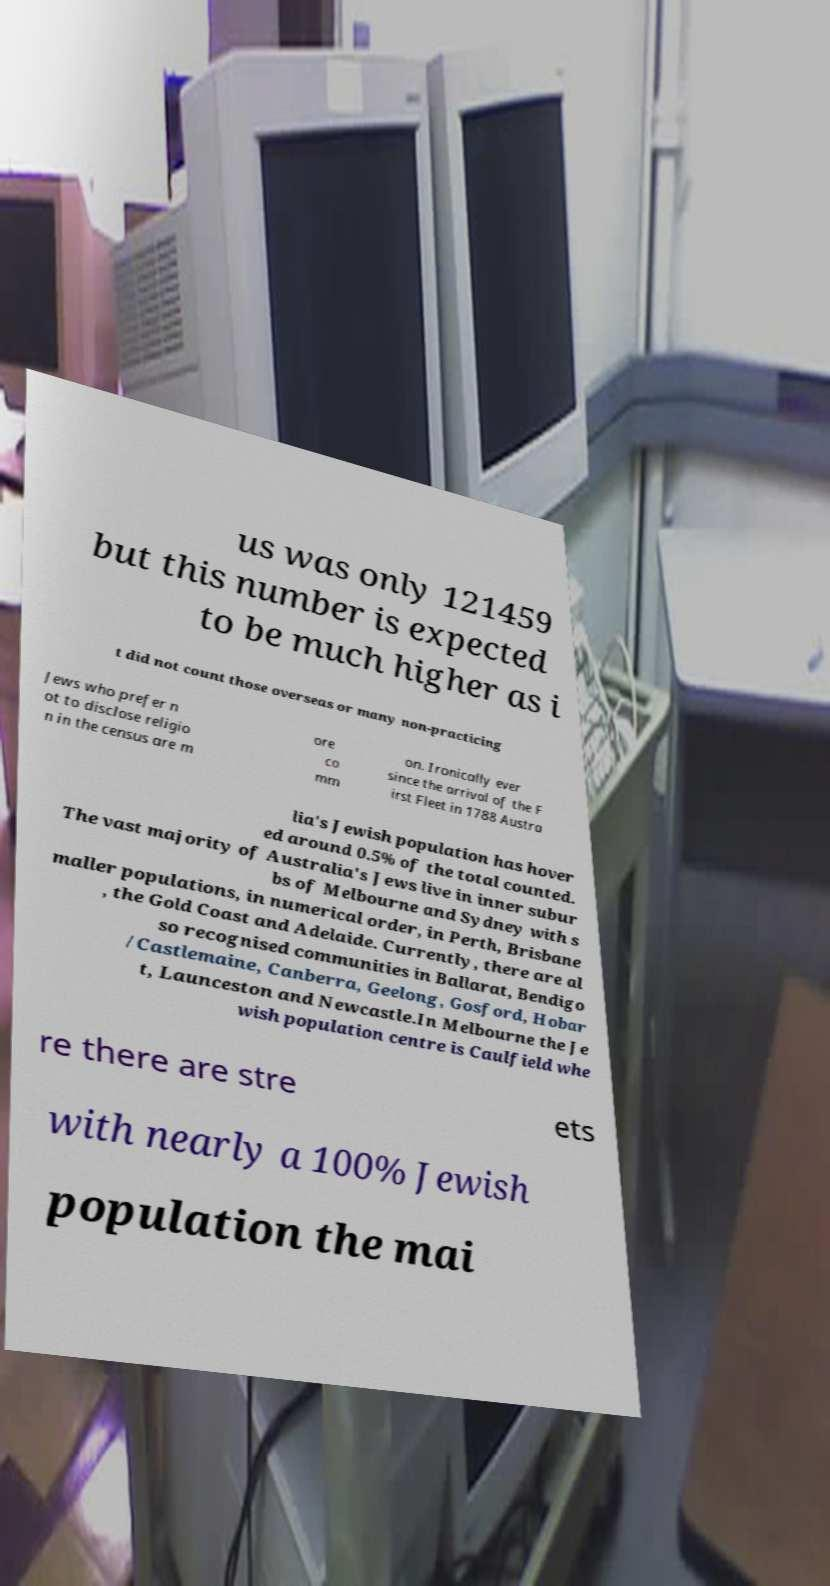What messages or text are displayed in this image? I need them in a readable, typed format. us was only 121459 but this number is expected to be much higher as i t did not count those overseas or many non-practicing Jews who prefer n ot to disclose religio n in the census are m ore co mm on. Ironically ever since the arrival of the F irst Fleet in 1788 Austra lia's Jewish population has hover ed around 0.5% of the total counted. The vast majority of Australia's Jews live in inner subur bs of Melbourne and Sydney with s maller populations, in numerical order, in Perth, Brisbane , the Gold Coast and Adelaide. Currently, there are al so recognised communities in Ballarat, Bendigo /Castlemaine, Canberra, Geelong, Gosford, Hobar t, Launceston and Newcastle.In Melbourne the Je wish population centre is Caulfield whe re there are stre ets with nearly a 100% Jewish population the mai 